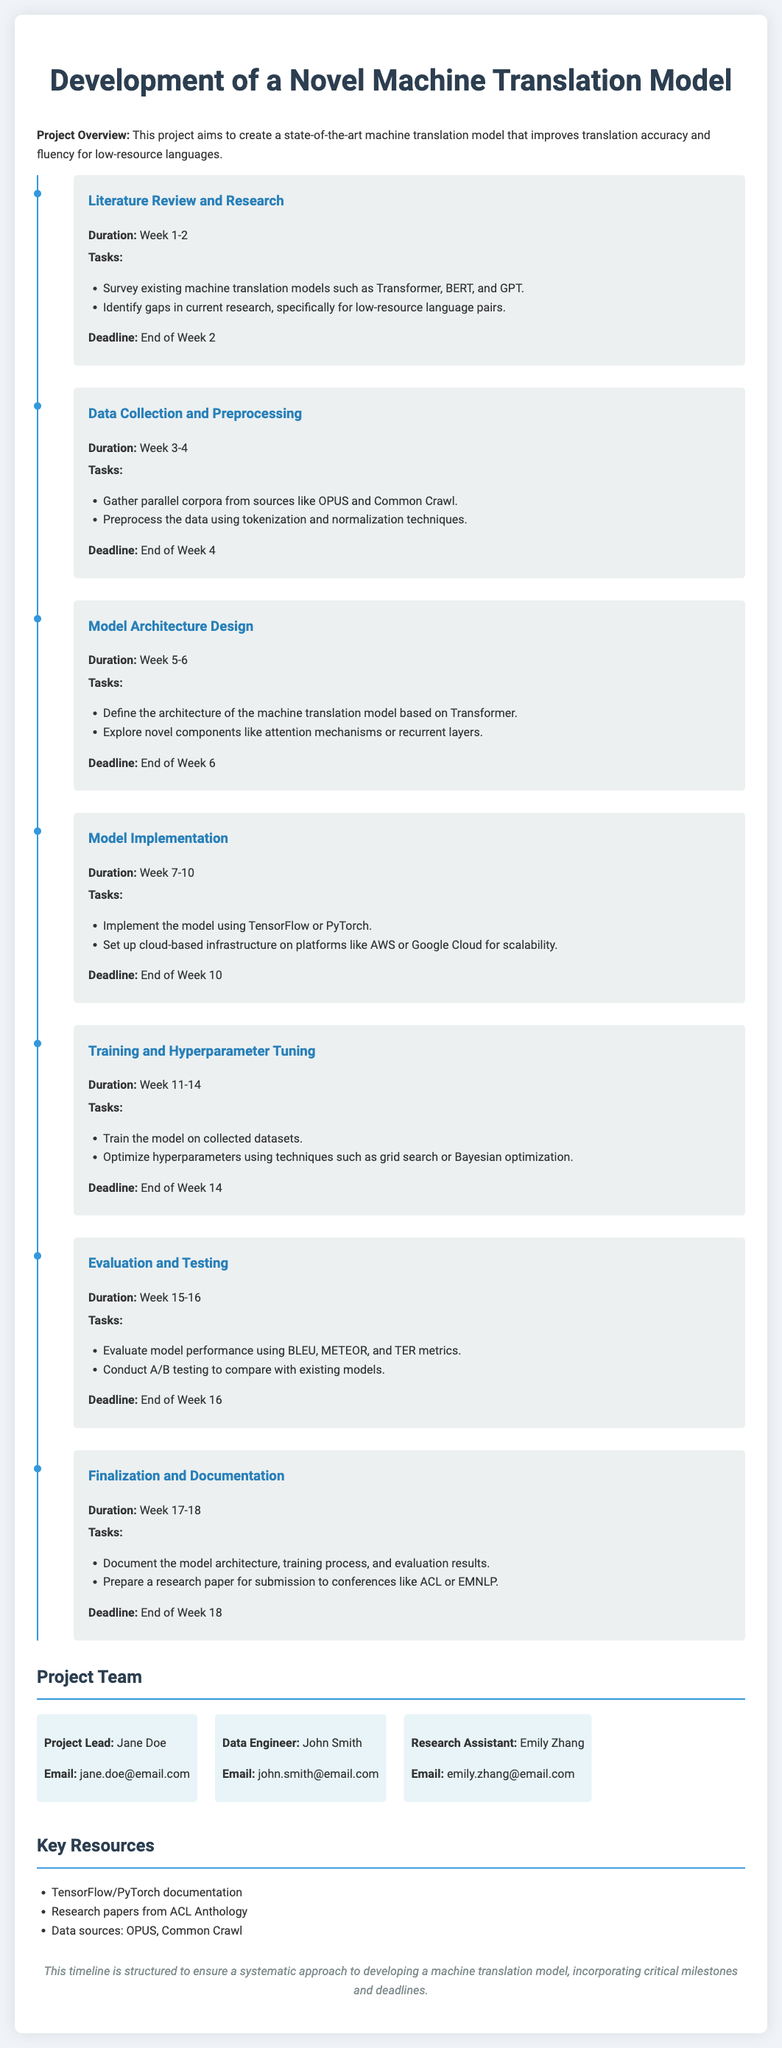What is the duration of the literature review? The duration of the literature review is specified in the project timeline, which states it lasts from Week 1 to Week 2.
Answer: Week 1-2 Who is the project lead? The document lists the team members and their roles, identifying Jane Doe as the project lead.
Answer: Jane Doe What are the key data sources for collection? The document outlines the data collection and preprocessing phase, mentioning OPUS and Common Crawl as key sources.
Answer: OPUS, Common Crawl What is the deadline for the evaluation and testing phase? The timeline indicates that the evaluation and testing phase must be completed by the end of Week 16.
Answer: End of Week 16 How many weeks are allocated for model implementation? The timeline specifies that model implementation occurs over four weeks, from Week 7 to Week 10.
Answer: 4 weeks What method is suggested for hyperparameter optimization? The document specifies techniques for hyperparameter optimization, suggesting grid search or Bayesian optimization.
Answer: Grid search, Bayesian optimization What type of infrastructure is recommended for model implementation? The timeline mentions setting up cloud-based infrastructure for scalability during the model implementation phase.
Answer: Cloud-based infrastructure What should be included in the documentation process? The documentation process must cover aspects such as model architecture, training process, and evaluation results, as stated in the finalization phase.
Answer: Model architecture, training process, evaluation results What is the focus of the project? The project overview states that the focus is on improving translation accuracy and fluency for low-resource languages.
Answer: Low-resource languages 